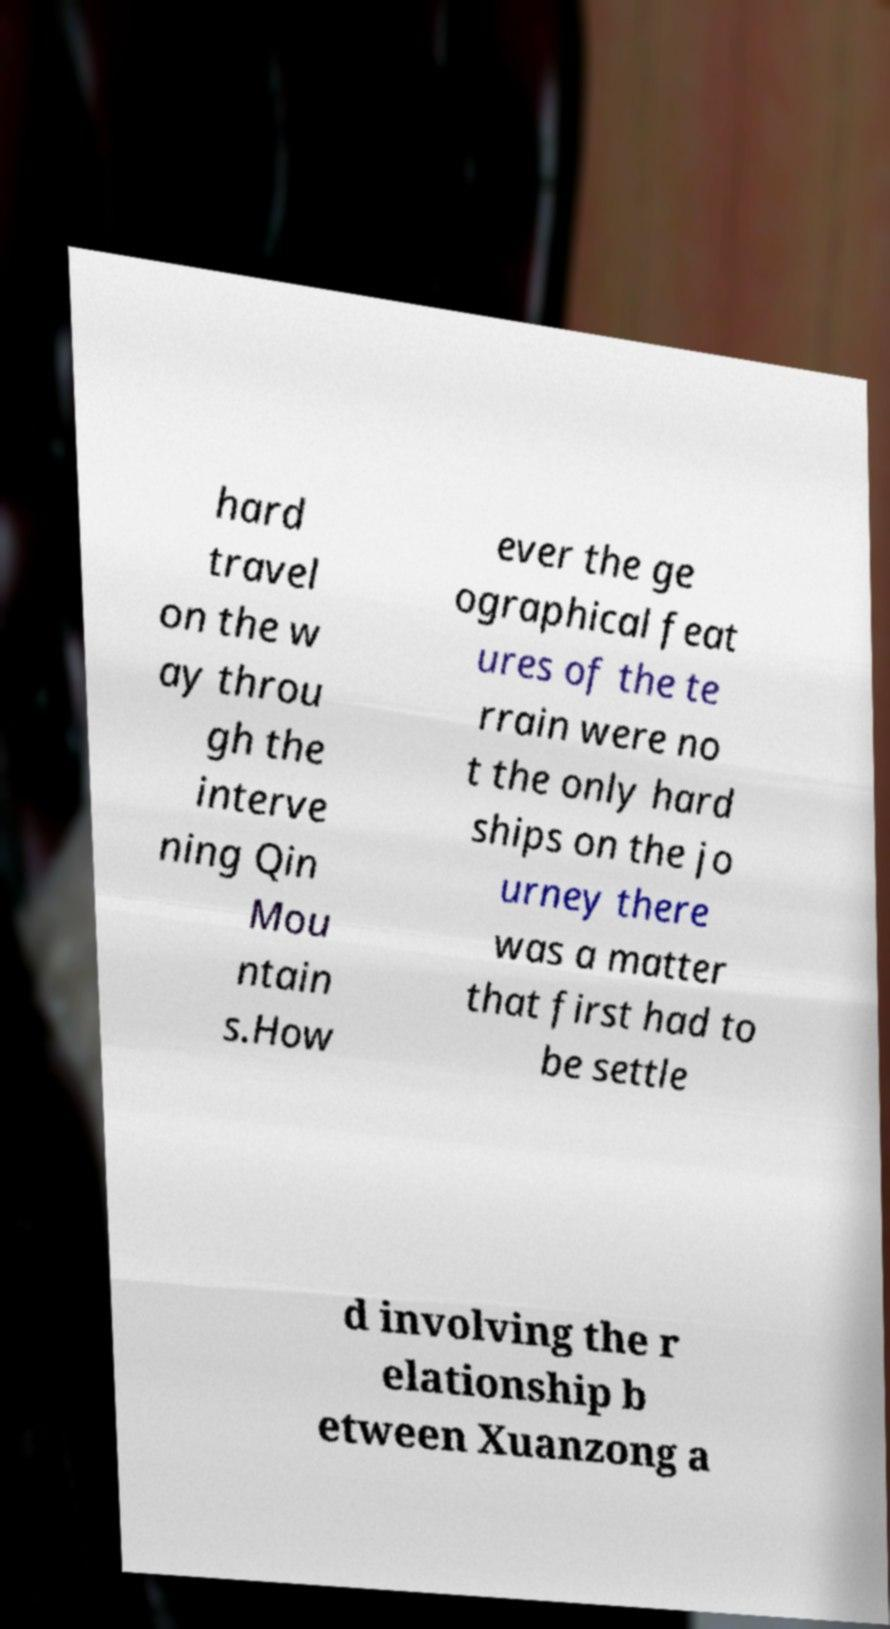Could you assist in decoding the text presented in this image and type it out clearly? hard travel on the w ay throu gh the interve ning Qin Mou ntain s.How ever the ge ographical feat ures of the te rrain were no t the only hard ships on the jo urney there was a matter that first had to be settle d involving the r elationship b etween Xuanzong a 